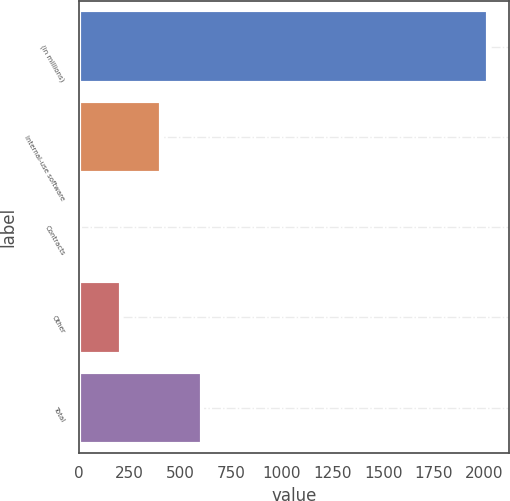Convert chart to OTSL. <chart><loc_0><loc_0><loc_500><loc_500><bar_chart><fcel>(in millions)<fcel>Internal-use software<fcel>Contracts<fcel>Other<fcel>Total<nl><fcel>2018<fcel>407.6<fcel>5<fcel>206.3<fcel>608.9<nl></chart> 